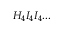Convert formula to latex. <formula><loc_0><loc_0><loc_500><loc_500>H _ { 4 } I _ { 4 } I _ { 4 } \dots</formula> 